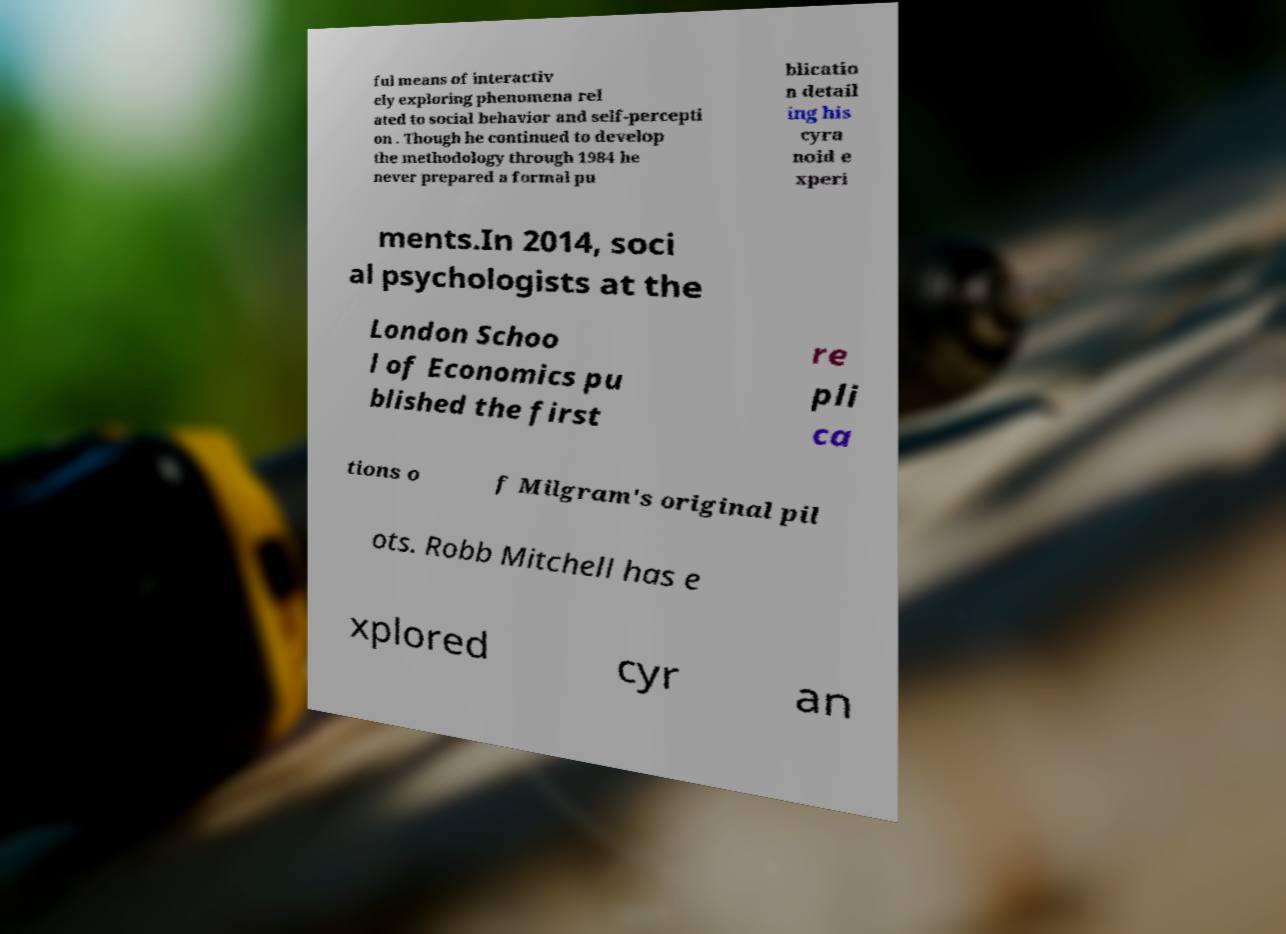For documentation purposes, I need the text within this image transcribed. Could you provide that? ful means of interactiv ely exploring phenomena rel ated to social behavior and self-percepti on . Though he continued to develop the methodology through 1984 he never prepared a formal pu blicatio n detail ing his cyra noid e xperi ments.In 2014, soci al psychologists at the London Schoo l of Economics pu blished the first re pli ca tions o f Milgram's original pil ots. Robb Mitchell has e xplored cyr an 